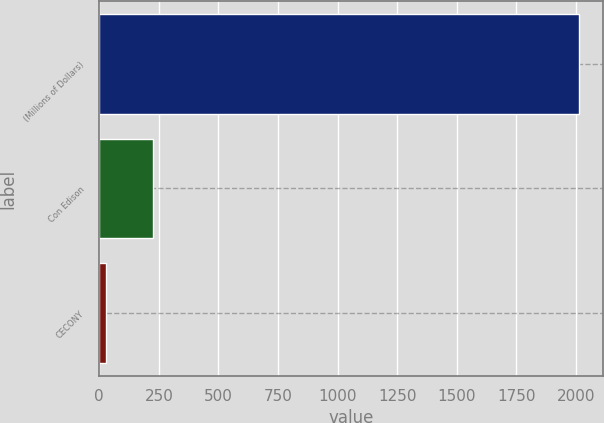<chart> <loc_0><loc_0><loc_500><loc_500><bar_chart><fcel>(Millions of Dollars)<fcel>Con Edison<fcel>CECONY<nl><fcel>2014<fcel>225.7<fcel>27<nl></chart> 